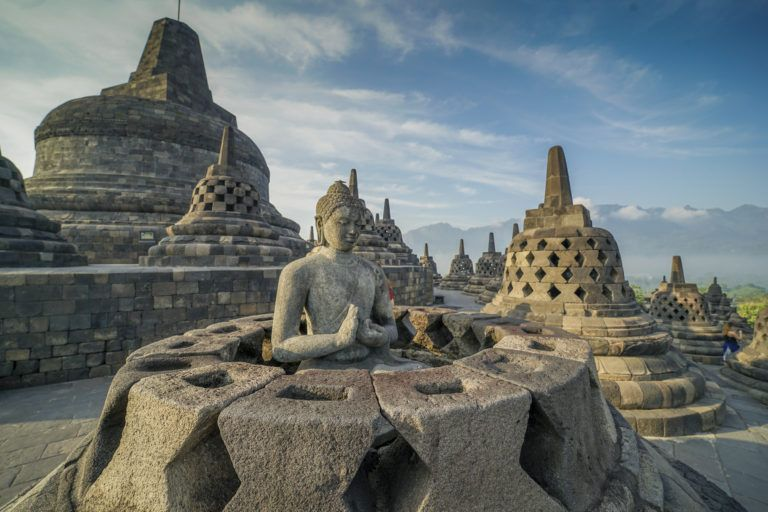What is the historical significance of this temple? Borobodur Temple, located in Central Java, Indonesia, is an incredible remnant of Buddhist architecture dating back to the 9th century. It is the largest Buddhist temple in the world and is renowned for its grand design and intricate decorations. The temple was built during the reign of the Sailendra Dynasty and was later abandoned and hidden under layers of volcanic ash and jungle. Rediscovered in the early 19th century, its restoration efforts have turned it into a major archaeological and cultural tourism site. It is a UNESCO World Heritage Site, revered for its historical, cultural, and spiritual significance. 